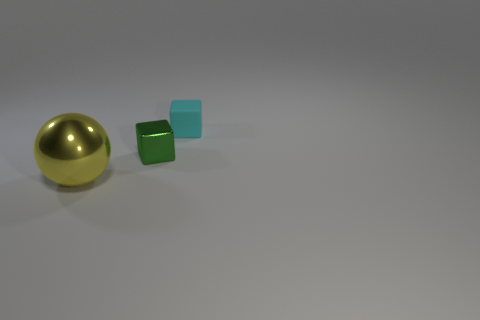Add 3 cyan objects. How many objects exist? 6 Subtract all cubes. How many objects are left? 1 Add 1 tiny blue shiny spheres. How many tiny blue shiny spheres exist? 1 Subtract 0 gray balls. How many objects are left? 3 Subtract all tiny metallic things. Subtract all tiny green metal objects. How many objects are left? 1 Add 1 small cyan matte things. How many small cyan matte things are left? 2 